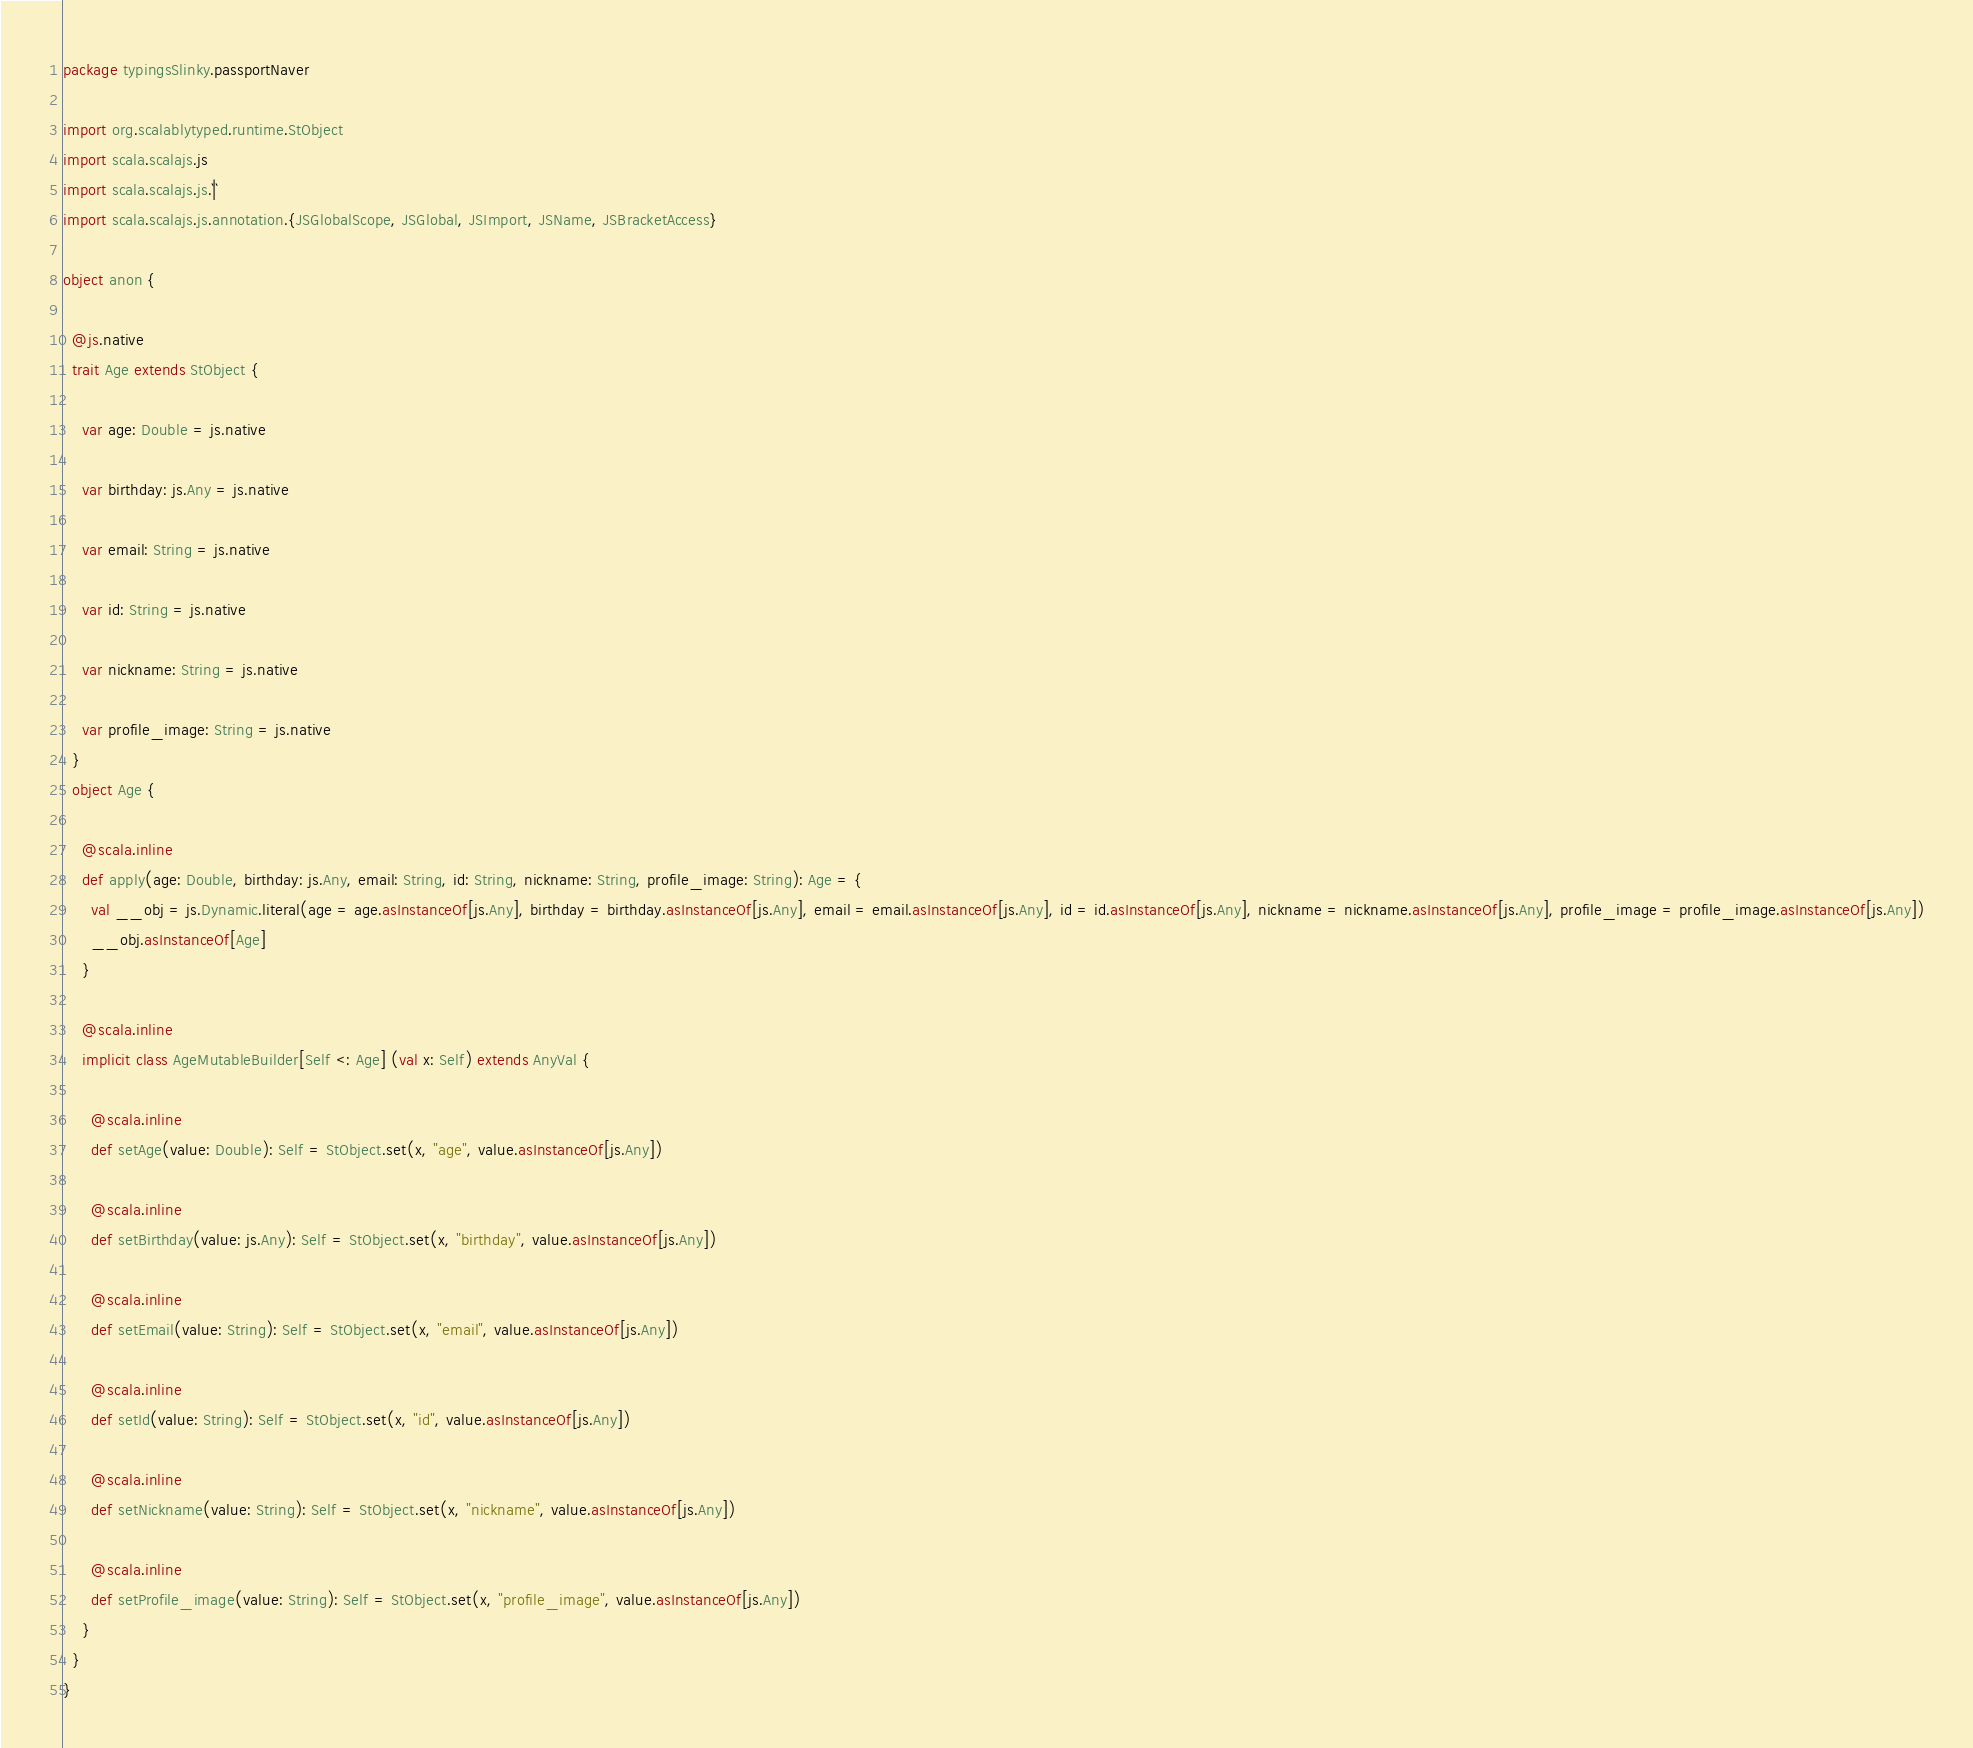<code> <loc_0><loc_0><loc_500><loc_500><_Scala_>package typingsSlinky.passportNaver

import org.scalablytyped.runtime.StObject
import scala.scalajs.js
import scala.scalajs.js.`|`
import scala.scalajs.js.annotation.{JSGlobalScope, JSGlobal, JSImport, JSName, JSBracketAccess}

object anon {
  
  @js.native
  trait Age extends StObject {
    
    var age: Double = js.native
    
    var birthday: js.Any = js.native
    
    var email: String = js.native
    
    var id: String = js.native
    
    var nickname: String = js.native
    
    var profile_image: String = js.native
  }
  object Age {
    
    @scala.inline
    def apply(age: Double, birthday: js.Any, email: String, id: String, nickname: String, profile_image: String): Age = {
      val __obj = js.Dynamic.literal(age = age.asInstanceOf[js.Any], birthday = birthday.asInstanceOf[js.Any], email = email.asInstanceOf[js.Any], id = id.asInstanceOf[js.Any], nickname = nickname.asInstanceOf[js.Any], profile_image = profile_image.asInstanceOf[js.Any])
      __obj.asInstanceOf[Age]
    }
    
    @scala.inline
    implicit class AgeMutableBuilder[Self <: Age] (val x: Self) extends AnyVal {
      
      @scala.inline
      def setAge(value: Double): Self = StObject.set(x, "age", value.asInstanceOf[js.Any])
      
      @scala.inline
      def setBirthday(value: js.Any): Self = StObject.set(x, "birthday", value.asInstanceOf[js.Any])
      
      @scala.inline
      def setEmail(value: String): Self = StObject.set(x, "email", value.asInstanceOf[js.Any])
      
      @scala.inline
      def setId(value: String): Self = StObject.set(x, "id", value.asInstanceOf[js.Any])
      
      @scala.inline
      def setNickname(value: String): Self = StObject.set(x, "nickname", value.asInstanceOf[js.Any])
      
      @scala.inline
      def setProfile_image(value: String): Self = StObject.set(x, "profile_image", value.asInstanceOf[js.Any])
    }
  }
}
</code> 